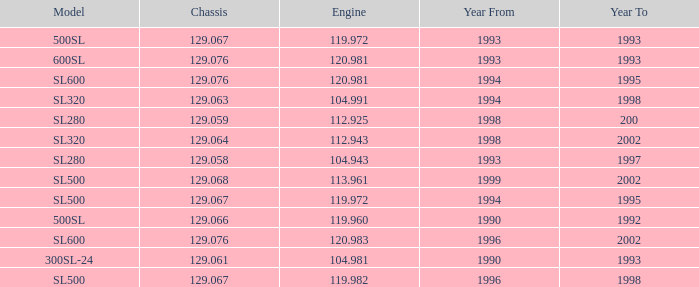Parse the table in full. {'header': ['Model', 'Chassis', 'Engine', 'Year From', 'Year To'], 'rows': [['500SL', '129.067', '119.972', '1993', '1993'], ['600SL', '129.076', '120.981', '1993', '1993'], ['SL600', '129.076', '120.981', '1994', '1995'], ['SL320', '129.063', '104.991', '1994', '1998'], ['SL280', '129.059', '112.925', '1998', '200'], ['SL320', '129.064', '112.943', '1998', '2002'], ['SL280', '129.058', '104.943', '1993', '1997'], ['SL500', '129.068', '113.961', '1999', '2002'], ['SL500', '129.067', '119.972', '1994', '1995'], ['500SL', '129.066', '119.960', '1990', '1992'], ['SL600', '129.076', '120.983', '1996', '2002'], ['300SL-24', '129.061', '104.981', '1990', '1993'], ['SL500', '129.067', '119.982', '1996', '1998']]} Which Engine has a Model of sl500, and a Year From larger than 1999? None. 